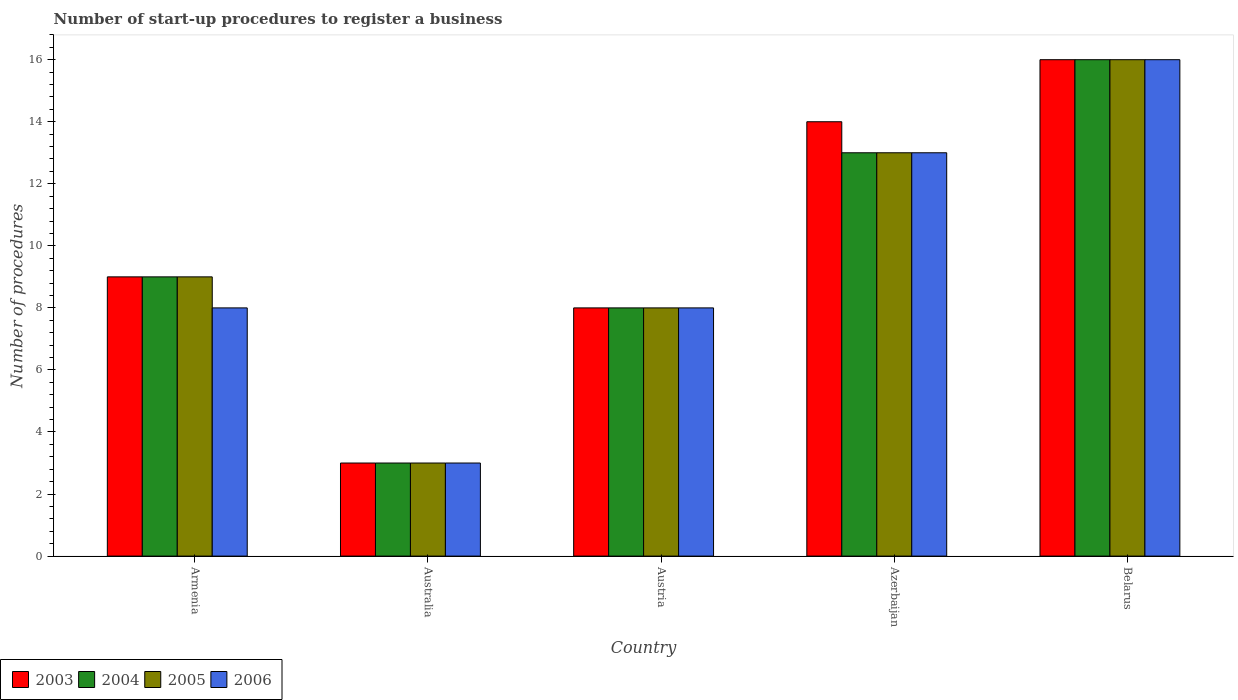How many different coloured bars are there?
Provide a succinct answer. 4. How many groups of bars are there?
Your answer should be very brief. 5. Are the number of bars on each tick of the X-axis equal?
Keep it short and to the point. Yes. How many bars are there on the 3rd tick from the left?
Provide a short and direct response. 4. What is the label of the 4th group of bars from the left?
Ensure brevity in your answer.  Azerbaijan. In how many cases, is the number of bars for a given country not equal to the number of legend labels?
Make the answer very short. 0. What is the number of procedures required to register a business in 2006 in Azerbaijan?
Your answer should be compact. 13. Across all countries, what is the minimum number of procedures required to register a business in 2004?
Your response must be concise. 3. In which country was the number of procedures required to register a business in 2004 maximum?
Offer a terse response. Belarus. In which country was the number of procedures required to register a business in 2005 minimum?
Ensure brevity in your answer.  Australia. What is the difference between the number of procedures required to register a business in 2003 in Australia and that in Austria?
Keep it short and to the point. -5. What is the difference between the number of procedures required to register a business in 2003 in Armenia and the number of procedures required to register a business in 2004 in Azerbaijan?
Your response must be concise. -4. What is the average number of procedures required to register a business in 2004 per country?
Offer a terse response. 9.8. In how many countries, is the number of procedures required to register a business in 2005 greater than 4?
Make the answer very short. 4. What is the ratio of the number of procedures required to register a business in 2005 in Armenia to that in Azerbaijan?
Offer a terse response. 0.69. Is the number of procedures required to register a business in 2004 in Armenia less than that in Austria?
Ensure brevity in your answer.  No. What is the difference between the highest and the second highest number of procedures required to register a business in 2006?
Provide a succinct answer. 8. In how many countries, is the number of procedures required to register a business in 2006 greater than the average number of procedures required to register a business in 2006 taken over all countries?
Offer a very short reply. 2. Is the sum of the number of procedures required to register a business in 2006 in Armenia and Australia greater than the maximum number of procedures required to register a business in 2003 across all countries?
Make the answer very short. No. Is it the case that in every country, the sum of the number of procedures required to register a business in 2003 and number of procedures required to register a business in 2005 is greater than the sum of number of procedures required to register a business in 2006 and number of procedures required to register a business in 2004?
Your answer should be compact. No. What does the 1st bar from the left in Belarus represents?
Give a very brief answer. 2003. What does the 4th bar from the right in Australia represents?
Give a very brief answer. 2003. Is it the case that in every country, the sum of the number of procedures required to register a business in 2003 and number of procedures required to register a business in 2006 is greater than the number of procedures required to register a business in 2005?
Offer a terse response. Yes. How many bars are there?
Ensure brevity in your answer.  20. How many legend labels are there?
Ensure brevity in your answer.  4. What is the title of the graph?
Offer a terse response. Number of start-up procedures to register a business. Does "2015" appear as one of the legend labels in the graph?
Ensure brevity in your answer.  No. What is the label or title of the X-axis?
Your response must be concise. Country. What is the label or title of the Y-axis?
Keep it short and to the point. Number of procedures. What is the Number of procedures in 2005 in Armenia?
Offer a terse response. 9. What is the Number of procedures of 2003 in Australia?
Provide a succinct answer. 3. What is the Number of procedures of 2004 in Australia?
Your answer should be very brief. 3. What is the Number of procedures in 2005 in Australia?
Make the answer very short. 3. What is the Number of procedures of 2006 in Australia?
Offer a terse response. 3. What is the Number of procedures in 2003 in Austria?
Provide a short and direct response. 8. What is the Number of procedures of 2006 in Austria?
Your answer should be compact. 8. What is the Number of procedures in 2005 in Azerbaijan?
Provide a succinct answer. 13. What is the Number of procedures of 2006 in Azerbaijan?
Provide a short and direct response. 13. What is the Number of procedures in 2003 in Belarus?
Make the answer very short. 16. What is the Number of procedures in 2005 in Belarus?
Your answer should be very brief. 16. What is the Number of procedures of 2006 in Belarus?
Provide a short and direct response. 16. Across all countries, what is the maximum Number of procedures in 2005?
Offer a terse response. 16. Across all countries, what is the maximum Number of procedures in 2006?
Your answer should be very brief. 16. Across all countries, what is the minimum Number of procedures in 2006?
Provide a succinct answer. 3. What is the total Number of procedures in 2005 in the graph?
Make the answer very short. 49. What is the difference between the Number of procedures of 2003 in Armenia and that in Australia?
Keep it short and to the point. 6. What is the difference between the Number of procedures of 2004 in Armenia and that in Australia?
Offer a very short reply. 6. What is the difference between the Number of procedures in 2006 in Armenia and that in Australia?
Your answer should be very brief. 5. What is the difference between the Number of procedures of 2003 in Armenia and that in Azerbaijan?
Make the answer very short. -5. What is the difference between the Number of procedures of 2004 in Armenia and that in Belarus?
Provide a short and direct response. -7. What is the difference between the Number of procedures in 2005 in Armenia and that in Belarus?
Your response must be concise. -7. What is the difference between the Number of procedures of 2005 in Australia and that in Austria?
Keep it short and to the point. -5. What is the difference between the Number of procedures in 2006 in Australia and that in Austria?
Give a very brief answer. -5. What is the difference between the Number of procedures of 2006 in Australia and that in Azerbaijan?
Ensure brevity in your answer.  -10. What is the difference between the Number of procedures in 2004 in Australia and that in Belarus?
Keep it short and to the point. -13. What is the difference between the Number of procedures of 2006 in Austria and that in Azerbaijan?
Make the answer very short. -5. What is the difference between the Number of procedures in 2003 in Austria and that in Belarus?
Ensure brevity in your answer.  -8. What is the difference between the Number of procedures of 2004 in Azerbaijan and that in Belarus?
Your answer should be compact. -3. What is the difference between the Number of procedures in 2006 in Azerbaijan and that in Belarus?
Your answer should be very brief. -3. What is the difference between the Number of procedures in 2003 in Armenia and the Number of procedures in 2005 in Australia?
Provide a succinct answer. 6. What is the difference between the Number of procedures in 2003 in Armenia and the Number of procedures in 2006 in Australia?
Provide a succinct answer. 6. What is the difference between the Number of procedures in 2005 in Armenia and the Number of procedures in 2006 in Australia?
Ensure brevity in your answer.  6. What is the difference between the Number of procedures of 2003 in Armenia and the Number of procedures of 2004 in Austria?
Offer a very short reply. 1. What is the difference between the Number of procedures of 2003 in Armenia and the Number of procedures of 2005 in Austria?
Provide a succinct answer. 1. What is the difference between the Number of procedures in 2004 in Armenia and the Number of procedures in 2006 in Austria?
Give a very brief answer. 1. What is the difference between the Number of procedures of 2003 in Armenia and the Number of procedures of 2004 in Azerbaijan?
Your answer should be compact. -4. What is the difference between the Number of procedures in 2003 in Armenia and the Number of procedures in 2005 in Azerbaijan?
Give a very brief answer. -4. What is the difference between the Number of procedures of 2004 in Armenia and the Number of procedures of 2005 in Azerbaijan?
Offer a very short reply. -4. What is the difference between the Number of procedures of 2004 in Armenia and the Number of procedures of 2006 in Azerbaijan?
Your response must be concise. -4. What is the difference between the Number of procedures in 2005 in Armenia and the Number of procedures in 2006 in Azerbaijan?
Make the answer very short. -4. What is the difference between the Number of procedures in 2003 in Armenia and the Number of procedures in 2004 in Belarus?
Offer a very short reply. -7. What is the difference between the Number of procedures of 2003 in Armenia and the Number of procedures of 2005 in Belarus?
Keep it short and to the point. -7. What is the difference between the Number of procedures of 2003 in Armenia and the Number of procedures of 2006 in Belarus?
Provide a succinct answer. -7. What is the difference between the Number of procedures of 2004 in Armenia and the Number of procedures of 2005 in Belarus?
Ensure brevity in your answer.  -7. What is the difference between the Number of procedures in 2005 in Armenia and the Number of procedures in 2006 in Belarus?
Offer a very short reply. -7. What is the difference between the Number of procedures in 2003 in Australia and the Number of procedures in 2004 in Austria?
Your answer should be very brief. -5. What is the difference between the Number of procedures of 2004 in Australia and the Number of procedures of 2005 in Azerbaijan?
Provide a short and direct response. -10. What is the difference between the Number of procedures of 2004 in Australia and the Number of procedures of 2006 in Azerbaijan?
Make the answer very short. -10. What is the difference between the Number of procedures in 2004 in Australia and the Number of procedures in 2006 in Belarus?
Provide a short and direct response. -13. What is the difference between the Number of procedures of 2005 in Australia and the Number of procedures of 2006 in Belarus?
Your answer should be compact. -13. What is the difference between the Number of procedures in 2003 in Austria and the Number of procedures in 2004 in Azerbaijan?
Your answer should be compact. -5. What is the difference between the Number of procedures in 2003 in Austria and the Number of procedures in 2005 in Azerbaijan?
Provide a short and direct response. -5. What is the difference between the Number of procedures of 2005 in Austria and the Number of procedures of 2006 in Azerbaijan?
Give a very brief answer. -5. What is the difference between the Number of procedures in 2003 in Austria and the Number of procedures in 2005 in Belarus?
Offer a terse response. -8. What is the difference between the Number of procedures of 2003 in Austria and the Number of procedures of 2006 in Belarus?
Give a very brief answer. -8. What is the difference between the Number of procedures of 2004 in Austria and the Number of procedures of 2005 in Belarus?
Provide a succinct answer. -8. What is the difference between the Number of procedures of 2003 in Azerbaijan and the Number of procedures of 2004 in Belarus?
Keep it short and to the point. -2. What is the difference between the Number of procedures in 2003 in Azerbaijan and the Number of procedures in 2005 in Belarus?
Provide a short and direct response. -2. What is the difference between the Number of procedures in 2003 in Azerbaijan and the Number of procedures in 2006 in Belarus?
Your response must be concise. -2. What is the difference between the Number of procedures in 2004 in Azerbaijan and the Number of procedures in 2006 in Belarus?
Offer a terse response. -3. What is the difference between the Number of procedures in 2005 in Azerbaijan and the Number of procedures in 2006 in Belarus?
Ensure brevity in your answer.  -3. What is the average Number of procedures of 2004 per country?
Give a very brief answer. 9.8. What is the average Number of procedures of 2005 per country?
Your answer should be very brief. 9.8. What is the average Number of procedures in 2006 per country?
Provide a short and direct response. 9.6. What is the difference between the Number of procedures in 2003 and Number of procedures in 2006 in Armenia?
Offer a terse response. 1. What is the difference between the Number of procedures of 2004 and Number of procedures of 2005 in Armenia?
Give a very brief answer. 0. What is the difference between the Number of procedures of 2004 and Number of procedures of 2006 in Armenia?
Provide a succinct answer. 1. What is the difference between the Number of procedures in 2005 and Number of procedures in 2006 in Armenia?
Offer a very short reply. 1. What is the difference between the Number of procedures in 2003 and Number of procedures in 2005 in Australia?
Provide a short and direct response. 0. What is the difference between the Number of procedures of 2004 and Number of procedures of 2006 in Australia?
Your answer should be compact. 0. What is the difference between the Number of procedures in 2003 and Number of procedures in 2004 in Austria?
Offer a terse response. 0. What is the difference between the Number of procedures of 2004 and Number of procedures of 2005 in Austria?
Ensure brevity in your answer.  0. What is the difference between the Number of procedures in 2005 and Number of procedures in 2006 in Austria?
Ensure brevity in your answer.  0. What is the difference between the Number of procedures in 2004 and Number of procedures in 2005 in Azerbaijan?
Your response must be concise. 0. What is the difference between the Number of procedures in 2004 and Number of procedures in 2006 in Azerbaijan?
Make the answer very short. 0. What is the difference between the Number of procedures in 2005 and Number of procedures in 2006 in Azerbaijan?
Keep it short and to the point. 0. What is the difference between the Number of procedures of 2003 and Number of procedures of 2004 in Belarus?
Ensure brevity in your answer.  0. What is the difference between the Number of procedures of 2003 and Number of procedures of 2006 in Belarus?
Give a very brief answer. 0. What is the difference between the Number of procedures of 2004 and Number of procedures of 2005 in Belarus?
Ensure brevity in your answer.  0. What is the difference between the Number of procedures of 2005 and Number of procedures of 2006 in Belarus?
Ensure brevity in your answer.  0. What is the ratio of the Number of procedures of 2003 in Armenia to that in Australia?
Offer a very short reply. 3. What is the ratio of the Number of procedures of 2006 in Armenia to that in Australia?
Your answer should be compact. 2.67. What is the ratio of the Number of procedures of 2004 in Armenia to that in Austria?
Offer a terse response. 1.12. What is the ratio of the Number of procedures of 2006 in Armenia to that in Austria?
Give a very brief answer. 1. What is the ratio of the Number of procedures in 2003 in Armenia to that in Azerbaijan?
Your answer should be compact. 0.64. What is the ratio of the Number of procedures of 2004 in Armenia to that in Azerbaijan?
Offer a terse response. 0.69. What is the ratio of the Number of procedures of 2005 in Armenia to that in Azerbaijan?
Your answer should be very brief. 0.69. What is the ratio of the Number of procedures in 2006 in Armenia to that in Azerbaijan?
Your answer should be compact. 0.62. What is the ratio of the Number of procedures of 2003 in Armenia to that in Belarus?
Keep it short and to the point. 0.56. What is the ratio of the Number of procedures of 2004 in Armenia to that in Belarus?
Your response must be concise. 0.56. What is the ratio of the Number of procedures in 2005 in Armenia to that in Belarus?
Provide a short and direct response. 0.56. What is the ratio of the Number of procedures in 2006 in Armenia to that in Belarus?
Ensure brevity in your answer.  0.5. What is the ratio of the Number of procedures of 2006 in Australia to that in Austria?
Provide a short and direct response. 0.38. What is the ratio of the Number of procedures of 2003 in Australia to that in Azerbaijan?
Make the answer very short. 0.21. What is the ratio of the Number of procedures of 2004 in Australia to that in Azerbaijan?
Ensure brevity in your answer.  0.23. What is the ratio of the Number of procedures in 2005 in Australia to that in Azerbaijan?
Make the answer very short. 0.23. What is the ratio of the Number of procedures of 2006 in Australia to that in Azerbaijan?
Offer a terse response. 0.23. What is the ratio of the Number of procedures in 2003 in Australia to that in Belarus?
Offer a very short reply. 0.19. What is the ratio of the Number of procedures of 2004 in Australia to that in Belarus?
Offer a very short reply. 0.19. What is the ratio of the Number of procedures in 2005 in Australia to that in Belarus?
Ensure brevity in your answer.  0.19. What is the ratio of the Number of procedures of 2006 in Australia to that in Belarus?
Provide a short and direct response. 0.19. What is the ratio of the Number of procedures of 2003 in Austria to that in Azerbaijan?
Your response must be concise. 0.57. What is the ratio of the Number of procedures of 2004 in Austria to that in Azerbaijan?
Your answer should be very brief. 0.62. What is the ratio of the Number of procedures in 2005 in Austria to that in Azerbaijan?
Provide a succinct answer. 0.62. What is the ratio of the Number of procedures of 2006 in Austria to that in Azerbaijan?
Ensure brevity in your answer.  0.62. What is the ratio of the Number of procedures of 2006 in Austria to that in Belarus?
Provide a short and direct response. 0.5. What is the ratio of the Number of procedures in 2004 in Azerbaijan to that in Belarus?
Your answer should be very brief. 0.81. What is the ratio of the Number of procedures of 2005 in Azerbaijan to that in Belarus?
Provide a succinct answer. 0.81. What is the ratio of the Number of procedures in 2006 in Azerbaijan to that in Belarus?
Your response must be concise. 0.81. What is the difference between the highest and the second highest Number of procedures in 2005?
Ensure brevity in your answer.  3. What is the difference between the highest and the second highest Number of procedures of 2006?
Offer a terse response. 3. What is the difference between the highest and the lowest Number of procedures in 2005?
Keep it short and to the point. 13. What is the difference between the highest and the lowest Number of procedures in 2006?
Your answer should be very brief. 13. 